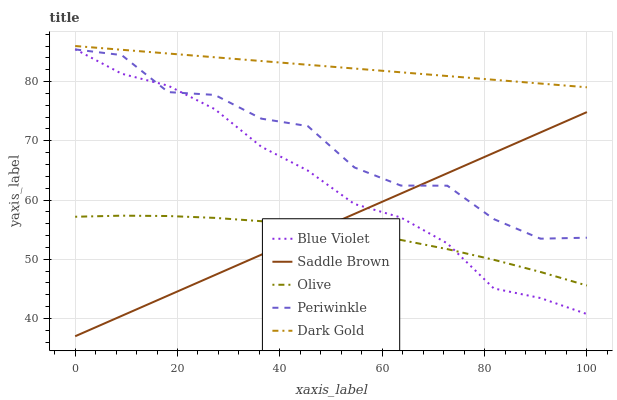Does Olive have the minimum area under the curve?
Answer yes or no. Yes. Does Dark Gold have the maximum area under the curve?
Answer yes or no. Yes. Does Periwinkle have the minimum area under the curve?
Answer yes or no. No. Does Periwinkle have the maximum area under the curve?
Answer yes or no. No. Is Dark Gold the smoothest?
Answer yes or no. Yes. Is Periwinkle the roughest?
Answer yes or no. Yes. Is Saddle Brown the smoothest?
Answer yes or no. No. Is Saddle Brown the roughest?
Answer yes or no. No. Does Saddle Brown have the lowest value?
Answer yes or no. Yes. Does Periwinkle have the lowest value?
Answer yes or no. No. Does Dark Gold have the highest value?
Answer yes or no. Yes. Does Periwinkle have the highest value?
Answer yes or no. No. Is Saddle Brown less than Dark Gold?
Answer yes or no. Yes. Is Dark Gold greater than Saddle Brown?
Answer yes or no. Yes. Does Saddle Brown intersect Blue Violet?
Answer yes or no. Yes. Is Saddle Brown less than Blue Violet?
Answer yes or no. No. Is Saddle Brown greater than Blue Violet?
Answer yes or no. No. Does Saddle Brown intersect Dark Gold?
Answer yes or no. No. 